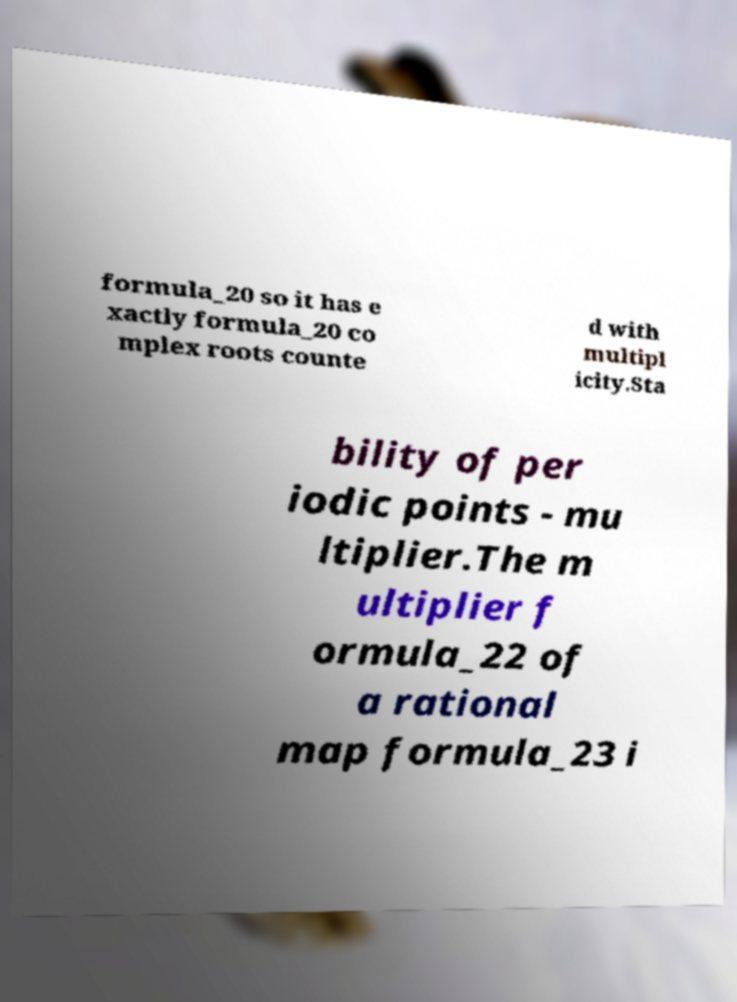Could you extract and type out the text from this image? formula_20 so it has e xactly formula_20 co mplex roots counte d with multipl icity.Sta bility of per iodic points - mu ltiplier.The m ultiplier f ormula_22 of a rational map formula_23 i 